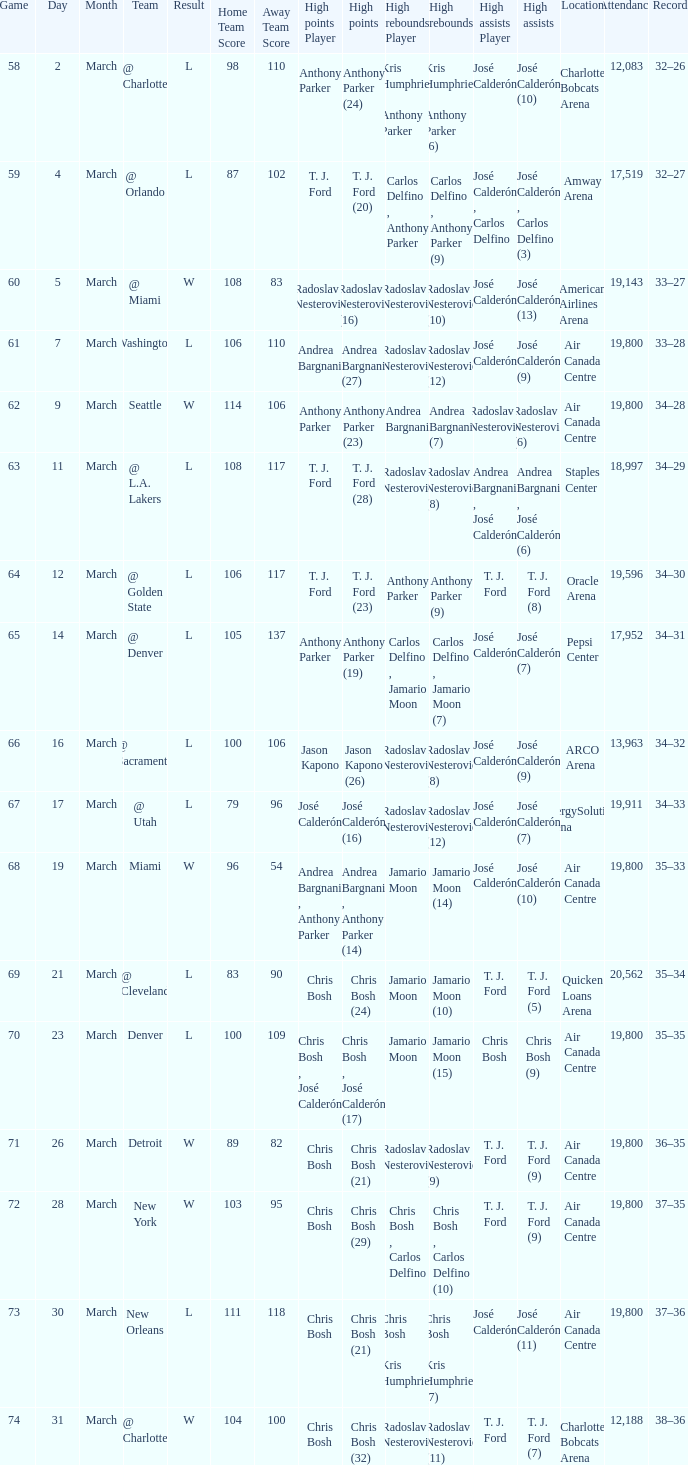What numbered game featured a High rebounds of radoslav nesterović (8), and a High assists of josé calderón (9)? 1.0. 